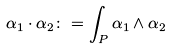Convert formula to latex. <formula><loc_0><loc_0><loc_500><loc_500>\alpha _ { 1 } \cdot \alpha _ { 2 } \colon = \int _ { P } \alpha _ { 1 } \wedge \alpha _ { 2 }</formula> 